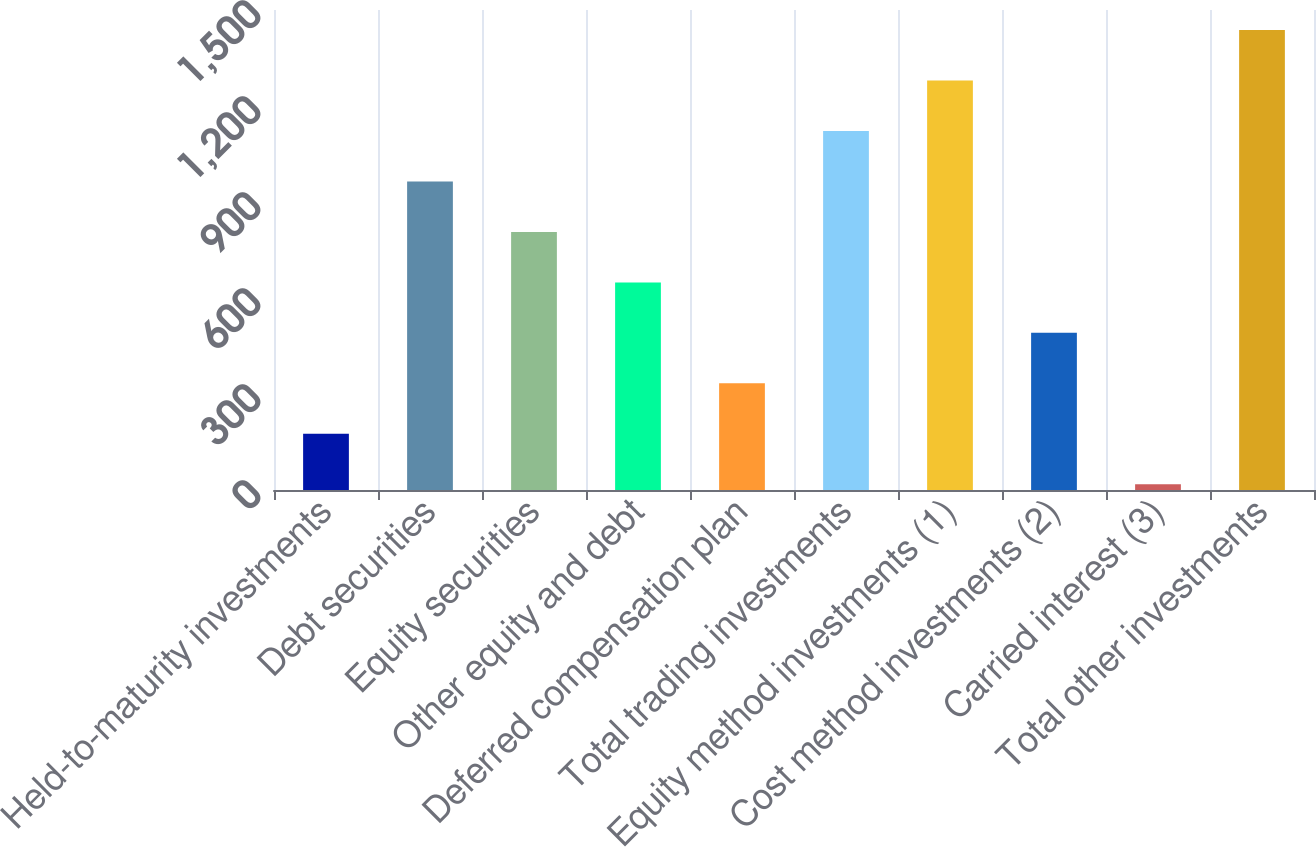Convert chart to OTSL. <chart><loc_0><loc_0><loc_500><loc_500><bar_chart><fcel>Held-to-maturity investments<fcel>Debt securities<fcel>Equity securities<fcel>Other equity and debt<fcel>Deferred compensation plan<fcel>Total trading investments<fcel>Equity method investments (1)<fcel>Cost method investments (2)<fcel>Carried interest (3)<fcel>Total other investments<nl><fcel>175.7<fcel>964.2<fcel>806.5<fcel>648.8<fcel>333.4<fcel>1121.9<fcel>1279.6<fcel>491.1<fcel>18<fcel>1437.3<nl></chart> 